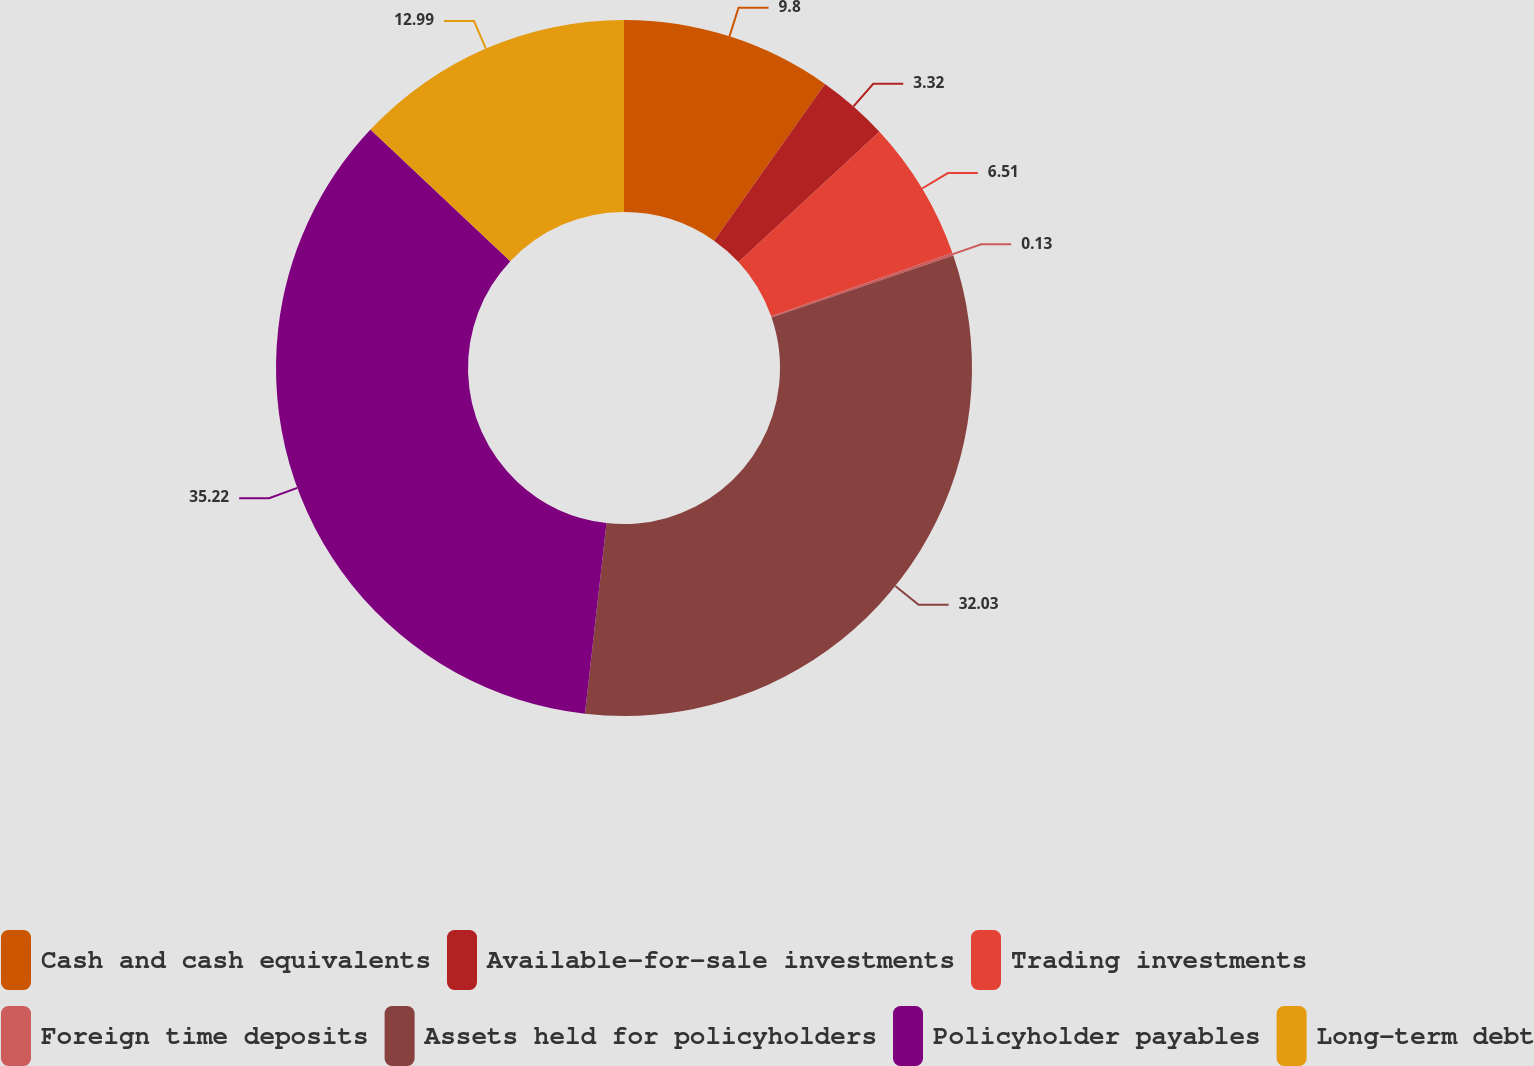<chart> <loc_0><loc_0><loc_500><loc_500><pie_chart><fcel>Cash and cash equivalents<fcel>Available-for-sale investments<fcel>Trading investments<fcel>Foreign time deposits<fcel>Assets held for policyholders<fcel>Policyholder payables<fcel>Long-term debt<nl><fcel>9.8%<fcel>3.32%<fcel>6.51%<fcel>0.13%<fcel>32.03%<fcel>35.22%<fcel>12.99%<nl></chart> 